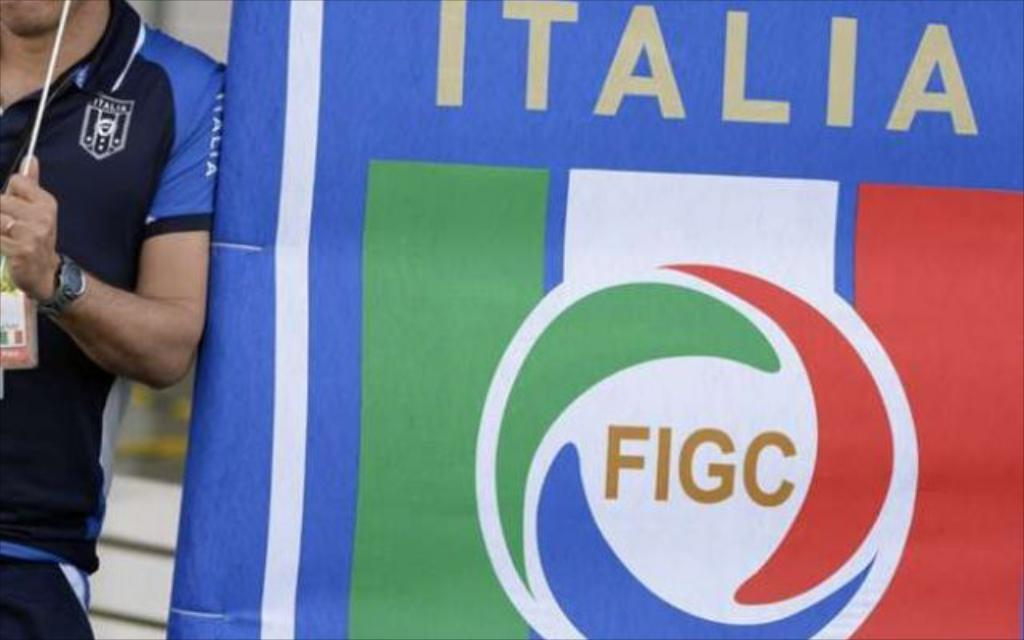<image>
Create a compact narrative representing the image presented. A man wearing an Italia soccer shirt is leaning against an Italia poster. 